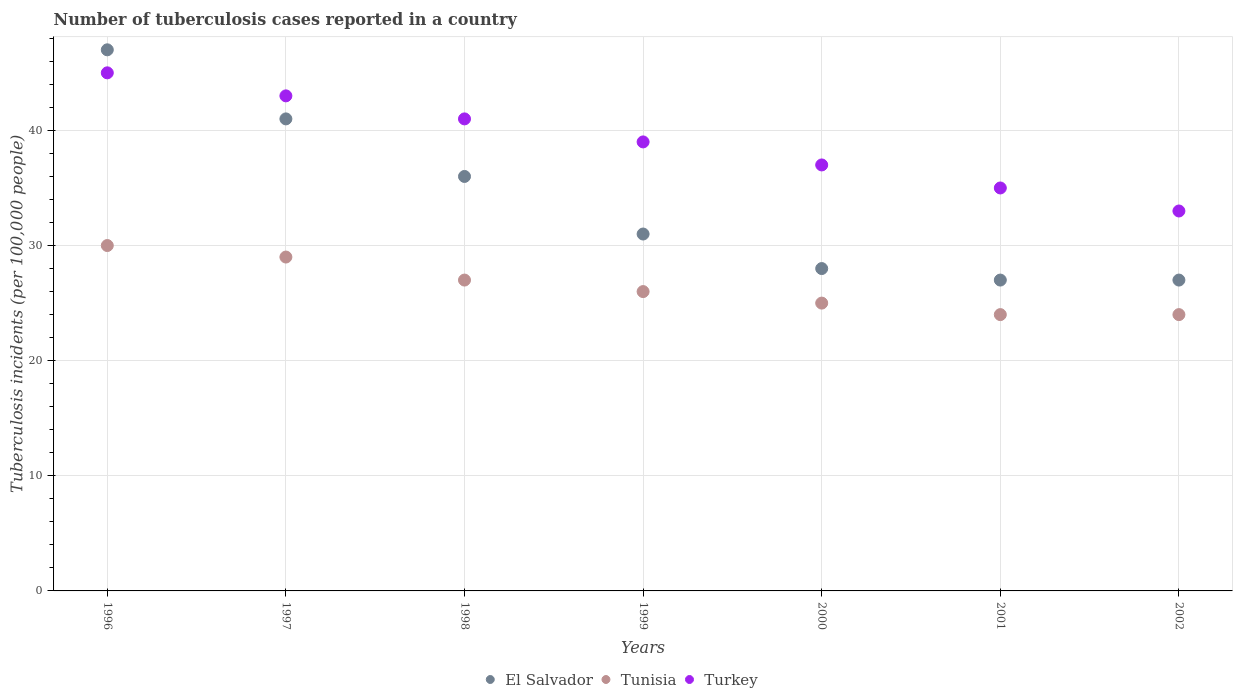What is the number of tuberculosis cases reported in in Turkey in 2000?
Make the answer very short. 37. Across all years, what is the maximum number of tuberculosis cases reported in in El Salvador?
Ensure brevity in your answer.  47. Across all years, what is the minimum number of tuberculosis cases reported in in El Salvador?
Provide a succinct answer. 27. In which year was the number of tuberculosis cases reported in in Turkey maximum?
Your response must be concise. 1996. In which year was the number of tuberculosis cases reported in in Tunisia minimum?
Your answer should be compact. 2001. What is the total number of tuberculosis cases reported in in Tunisia in the graph?
Give a very brief answer. 185. What is the difference between the number of tuberculosis cases reported in in Turkey in 2001 and the number of tuberculosis cases reported in in El Salvador in 2000?
Ensure brevity in your answer.  7. What is the average number of tuberculosis cases reported in in El Salvador per year?
Your answer should be very brief. 33.86. In the year 2001, what is the difference between the number of tuberculosis cases reported in in Tunisia and number of tuberculosis cases reported in in Turkey?
Your answer should be compact. -11. In how many years, is the number of tuberculosis cases reported in in Turkey greater than 32?
Your answer should be compact. 7. What is the ratio of the number of tuberculosis cases reported in in Turkey in 1997 to that in 1999?
Your answer should be compact. 1.1. Is the number of tuberculosis cases reported in in Turkey in 1998 less than that in 2001?
Ensure brevity in your answer.  No. What is the difference between the highest and the second highest number of tuberculosis cases reported in in El Salvador?
Provide a succinct answer. 6. What is the difference between the highest and the lowest number of tuberculosis cases reported in in Turkey?
Provide a short and direct response. 12. Is the sum of the number of tuberculosis cases reported in in Turkey in 1998 and 1999 greater than the maximum number of tuberculosis cases reported in in Tunisia across all years?
Provide a short and direct response. Yes. Is it the case that in every year, the sum of the number of tuberculosis cases reported in in Turkey and number of tuberculosis cases reported in in Tunisia  is greater than the number of tuberculosis cases reported in in El Salvador?
Your response must be concise. Yes. Is the number of tuberculosis cases reported in in Tunisia strictly greater than the number of tuberculosis cases reported in in El Salvador over the years?
Make the answer very short. No. Is the number of tuberculosis cases reported in in Turkey strictly less than the number of tuberculosis cases reported in in Tunisia over the years?
Your response must be concise. No. Does the graph contain any zero values?
Keep it short and to the point. No. How many legend labels are there?
Ensure brevity in your answer.  3. What is the title of the graph?
Offer a very short reply. Number of tuberculosis cases reported in a country. What is the label or title of the Y-axis?
Make the answer very short. Tuberculosis incidents (per 100,0 people). What is the Tuberculosis incidents (per 100,000 people) of Tunisia in 1996?
Your answer should be very brief. 30. What is the Tuberculosis incidents (per 100,000 people) in El Salvador in 1998?
Provide a short and direct response. 36. What is the Tuberculosis incidents (per 100,000 people) in Turkey in 1998?
Give a very brief answer. 41. What is the Tuberculosis incidents (per 100,000 people) in El Salvador in 1999?
Keep it short and to the point. 31. What is the Tuberculosis incidents (per 100,000 people) in El Salvador in 2000?
Your answer should be compact. 28. What is the Tuberculosis incidents (per 100,000 people) in Tunisia in 2000?
Keep it short and to the point. 25. What is the Tuberculosis incidents (per 100,000 people) in Turkey in 2000?
Make the answer very short. 37. What is the Tuberculosis incidents (per 100,000 people) in El Salvador in 2001?
Your response must be concise. 27. What is the Tuberculosis incidents (per 100,000 people) of Tunisia in 2001?
Ensure brevity in your answer.  24. What is the Tuberculosis incidents (per 100,000 people) in Turkey in 2001?
Provide a succinct answer. 35. Across all years, what is the maximum Tuberculosis incidents (per 100,000 people) of Tunisia?
Your answer should be compact. 30. Across all years, what is the maximum Tuberculosis incidents (per 100,000 people) of Turkey?
Make the answer very short. 45. Across all years, what is the minimum Tuberculosis incidents (per 100,000 people) of El Salvador?
Your response must be concise. 27. Across all years, what is the minimum Tuberculosis incidents (per 100,000 people) of Turkey?
Your response must be concise. 33. What is the total Tuberculosis incidents (per 100,000 people) of El Salvador in the graph?
Keep it short and to the point. 237. What is the total Tuberculosis incidents (per 100,000 people) in Tunisia in the graph?
Offer a very short reply. 185. What is the total Tuberculosis incidents (per 100,000 people) in Turkey in the graph?
Your answer should be compact. 273. What is the difference between the Tuberculosis incidents (per 100,000 people) in El Salvador in 1996 and that in 1997?
Keep it short and to the point. 6. What is the difference between the Tuberculosis incidents (per 100,000 people) of Turkey in 1996 and that in 1997?
Provide a short and direct response. 2. What is the difference between the Tuberculosis incidents (per 100,000 people) of Tunisia in 1996 and that in 1998?
Provide a succinct answer. 3. What is the difference between the Tuberculosis incidents (per 100,000 people) of Turkey in 1996 and that in 1998?
Ensure brevity in your answer.  4. What is the difference between the Tuberculosis incidents (per 100,000 people) of Turkey in 1996 and that in 2000?
Your answer should be very brief. 8. What is the difference between the Tuberculosis incidents (per 100,000 people) of Tunisia in 1996 and that in 2001?
Your answer should be very brief. 6. What is the difference between the Tuberculosis incidents (per 100,000 people) of El Salvador in 1996 and that in 2002?
Give a very brief answer. 20. What is the difference between the Tuberculosis incidents (per 100,000 people) in Tunisia in 1996 and that in 2002?
Your answer should be very brief. 6. What is the difference between the Tuberculosis incidents (per 100,000 people) in Turkey in 1996 and that in 2002?
Give a very brief answer. 12. What is the difference between the Tuberculosis incidents (per 100,000 people) in Turkey in 1997 and that in 1998?
Offer a very short reply. 2. What is the difference between the Tuberculosis incidents (per 100,000 people) of El Salvador in 1997 and that in 1999?
Your answer should be compact. 10. What is the difference between the Tuberculosis incidents (per 100,000 people) of Tunisia in 1997 and that in 1999?
Your answer should be very brief. 3. What is the difference between the Tuberculosis incidents (per 100,000 people) in El Salvador in 1997 and that in 2000?
Offer a very short reply. 13. What is the difference between the Tuberculosis incidents (per 100,000 people) of Tunisia in 1997 and that in 2000?
Offer a terse response. 4. What is the difference between the Tuberculosis incidents (per 100,000 people) of El Salvador in 1997 and that in 2001?
Keep it short and to the point. 14. What is the difference between the Tuberculosis incidents (per 100,000 people) in Tunisia in 1997 and that in 2001?
Make the answer very short. 5. What is the difference between the Tuberculosis incidents (per 100,000 people) in Turkey in 1997 and that in 2001?
Your answer should be very brief. 8. What is the difference between the Tuberculosis incidents (per 100,000 people) of Tunisia in 1997 and that in 2002?
Offer a terse response. 5. What is the difference between the Tuberculosis incidents (per 100,000 people) of Turkey in 1997 and that in 2002?
Offer a terse response. 10. What is the difference between the Tuberculosis incidents (per 100,000 people) of Tunisia in 1998 and that in 1999?
Ensure brevity in your answer.  1. What is the difference between the Tuberculosis incidents (per 100,000 people) of Tunisia in 1998 and that in 2000?
Make the answer very short. 2. What is the difference between the Tuberculosis incidents (per 100,000 people) of Turkey in 1998 and that in 2000?
Ensure brevity in your answer.  4. What is the difference between the Tuberculosis incidents (per 100,000 people) in Tunisia in 1998 and that in 2001?
Offer a very short reply. 3. What is the difference between the Tuberculosis incidents (per 100,000 people) of Turkey in 1998 and that in 2001?
Make the answer very short. 6. What is the difference between the Tuberculosis incidents (per 100,000 people) of El Salvador in 1998 and that in 2002?
Your answer should be very brief. 9. What is the difference between the Tuberculosis incidents (per 100,000 people) in Tunisia in 1998 and that in 2002?
Give a very brief answer. 3. What is the difference between the Tuberculosis incidents (per 100,000 people) in Turkey in 1998 and that in 2002?
Your answer should be compact. 8. What is the difference between the Tuberculosis incidents (per 100,000 people) of Turkey in 1999 and that in 2001?
Make the answer very short. 4. What is the difference between the Tuberculosis incidents (per 100,000 people) in Tunisia in 1999 and that in 2002?
Your response must be concise. 2. What is the difference between the Tuberculosis incidents (per 100,000 people) in Tunisia in 2000 and that in 2001?
Your answer should be very brief. 1. What is the difference between the Tuberculosis incidents (per 100,000 people) in Turkey in 2000 and that in 2002?
Your answer should be compact. 4. What is the difference between the Tuberculosis incidents (per 100,000 people) in Tunisia in 2001 and that in 2002?
Offer a terse response. 0. What is the difference between the Tuberculosis incidents (per 100,000 people) of Turkey in 2001 and that in 2002?
Keep it short and to the point. 2. What is the difference between the Tuberculosis incidents (per 100,000 people) of El Salvador in 1996 and the Tuberculosis incidents (per 100,000 people) of Tunisia in 1998?
Provide a short and direct response. 20. What is the difference between the Tuberculosis incidents (per 100,000 people) of El Salvador in 1996 and the Tuberculosis incidents (per 100,000 people) of Tunisia in 1999?
Offer a very short reply. 21. What is the difference between the Tuberculosis incidents (per 100,000 people) in El Salvador in 1996 and the Tuberculosis incidents (per 100,000 people) in Tunisia in 2001?
Provide a succinct answer. 23. What is the difference between the Tuberculosis incidents (per 100,000 people) in El Salvador in 1996 and the Tuberculosis incidents (per 100,000 people) in Turkey in 2001?
Your answer should be compact. 12. What is the difference between the Tuberculosis incidents (per 100,000 people) in Tunisia in 1996 and the Tuberculosis incidents (per 100,000 people) in Turkey in 2001?
Provide a short and direct response. -5. What is the difference between the Tuberculosis incidents (per 100,000 people) in El Salvador in 1996 and the Tuberculosis incidents (per 100,000 people) in Tunisia in 2002?
Make the answer very short. 23. What is the difference between the Tuberculosis incidents (per 100,000 people) in El Salvador in 1996 and the Tuberculosis incidents (per 100,000 people) in Turkey in 2002?
Keep it short and to the point. 14. What is the difference between the Tuberculosis incidents (per 100,000 people) of El Salvador in 1997 and the Tuberculosis incidents (per 100,000 people) of Turkey in 1998?
Your answer should be very brief. 0. What is the difference between the Tuberculosis incidents (per 100,000 people) of El Salvador in 1997 and the Tuberculosis incidents (per 100,000 people) of Turkey in 1999?
Offer a terse response. 2. What is the difference between the Tuberculosis incidents (per 100,000 people) of El Salvador in 1997 and the Tuberculosis incidents (per 100,000 people) of Turkey in 2000?
Ensure brevity in your answer.  4. What is the difference between the Tuberculosis incidents (per 100,000 people) of El Salvador in 1997 and the Tuberculosis incidents (per 100,000 people) of Tunisia in 2002?
Your answer should be compact. 17. What is the difference between the Tuberculosis incidents (per 100,000 people) of El Salvador in 1997 and the Tuberculosis incidents (per 100,000 people) of Turkey in 2002?
Keep it short and to the point. 8. What is the difference between the Tuberculosis incidents (per 100,000 people) in El Salvador in 1998 and the Tuberculosis incidents (per 100,000 people) in Tunisia in 1999?
Your answer should be compact. 10. What is the difference between the Tuberculosis incidents (per 100,000 people) of El Salvador in 1998 and the Tuberculosis incidents (per 100,000 people) of Turkey in 1999?
Provide a succinct answer. -3. What is the difference between the Tuberculosis incidents (per 100,000 people) in El Salvador in 1998 and the Tuberculosis incidents (per 100,000 people) in Turkey in 2000?
Keep it short and to the point. -1. What is the difference between the Tuberculosis incidents (per 100,000 people) of Tunisia in 1998 and the Tuberculosis incidents (per 100,000 people) of Turkey in 2000?
Your answer should be very brief. -10. What is the difference between the Tuberculosis incidents (per 100,000 people) in El Salvador in 1998 and the Tuberculosis incidents (per 100,000 people) in Turkey in 2001?
Make the answer very short. 1. What is the difference between the Tuberculosis incidents (per 100,000 people) of Tunisia in 1998 and the Tuberculosis incidents (per 100,000 people) of Turkey in 2001?
Ensure brevity in your answer.  -8. What is the difference between the Tuberculosis incidents (per 100,000 people) of El Salvador in 1998 and the Tuberculosis incidents (per 100,000 people) of Turkey in 2002?
Ensure brevity in your answer.  3. What is the difference between the Tuberculosis incidents (per 100,000 people) of El Salvador in 1999 and the Tuberculosis incidents (per 100,000 people) of Turkey in 2000?
Give a very brief answer. -6. What is the difference between the Tuberculosis incidents (per 100,000 people) in Tunisia in 1999 and the Tuberculosis incidents (per 100,000 people) in Turkey in 2000?
Make the answer very short. -11. What is the difference between the Tuberculosis incidents (per 100,000 people) in El Salvador in 1999 and the Tuberculosis incidents (per 100,000 people) in Turkey in 2001?
Provide a succinct answer. -4. What is the difference between the Tuberculosis incidents (per 100,000 people) of Tunisia in 1999 and the Tuberculosis incidents (per 100,000 people) of Turkey in 2001?
Offer a very short reply. -9. What is the difference between the Tuberculosis incidents (per 100,000 people) of El Salvador in 1999 and the Tuberculosis incidents (per 100,000 people) of Tunisia in 2002?
Give a very brief answer. 7. What is the difference between the Tuberculosis incidents (per 100,000 people) of Tunisia in 1999 and the Tuberculosis incidents (per 100,000 people) of Turkey in 2002?
Provide a short and direct response. -7. What is the difference between the Tuberculosis incidents (per 100,000 people) of El Salvador in 2000 and the Tuberculosis incidents (per 100,000 people) of Tunisia in 2001?
Make the answer very short. 4. What is the difference between the Tuberculosis incidents (per 100,000 people) of El Salvador in 2000 and the Tuberculosis incidents (per 100,000 people) of Turkey in 2001?
Offer a very short reply. -7. What is the difference between the Tuberculosis incidents (per 100,000 people) in El Salvador in 2000 and the Tuberculosis incidents (per 100,000 people) in Tunisia in 2002?
Provide a succinct answer. 4. What is the difference between the Tuberculosis incidents (per 100,000 people) of El Salvador in 2000 and the Tuberculosis incidents (per 100,000 people) of Turkey in 2002?
Your response must be concise. -5. What is the difference between the Tuberculosis incidents (per 100,000 people) of Tunisia in 2000 and the Tuberculosis incidents (per 100,000 people) of Turkey in 2002?
Provide a short and direct response. -8. What is the difference between the Tuberculosis incidents (per 100,000 people) in El Salvador in 2001 and the Tuberculosis incidents (per 100,000 people) in Tunisia in 2002?
Keep it short and to the point. 3. What is the difference between the Tuberculosis incidents (per 100,000 people) in El Salvador in 2001 and the Tuberculosis incidents (per 100,000 people) in Turkey in 2002?
Make the answer very short. -6. What is the average Tuberculosis incidents (per 100,000 people) in El Salvador per year?
Offer a terse response. 33.86. What is the average Tuberculosis incidents (per 100,000 people) of Tunisia per year?
Your response must be concise. 26.43. What is the average Tuberculosis incidents (per 100,000 people) in Turkey per year?
Offer a very short reply. 39. In the year 1996, what is the difference between the Tuberculosis incidents (per 100,000 people) of Tunisia and Tuberculosis incidents (per 100,000 people) of Turkey?
Provide a succinct answer. -15. In the year 1997, what is the difference between the Tuberculosis incidents (per 100,000 people) of Tunisia and Tuberculosis incidents (per 100,000 people) of Turkey?
Ensure brevity in your answer.  -14. In the year 1998, what is the difference between the Tuberculosis incidents (per 100,000 people) in El Salvador and Tuberculosis incidents (per 100,000 people) in Tunisia?
Give a very brief answer. 9. In the year 1999, what is the difference between the Tuberculosis incidents (per 100,000 people) of El Salvador and Tuberculosis incidents (per 100,000 people) of Tunisia?
Ensure brevity in your answer.  5. In the year 1999, what is the difference between the Tuberculosis incidents (per 100,000 people) of El Salvador and Tuberculosis incidents (per 100,000 people) of Turkey?
Your answer should be compact. -8. In the year 2000, what is the difference between the Tuberculosis incidents (per 100,000 people) in El Salvador and Tuberculosis incidents (per 100,000 people) in Turkey?
Offer a terse response. -9. In the year 2001, what is the difference between the Tuberculosis incidents (per 100,000 people) in El Salvador and Tuberculosis incidents (per 100,000 people) in Tunisia?
Your answer should be very brief. 3. In the year 2001, what is the difference between the Tuberculosis incidents (per 100,000 people) in Tunisia and Tuberculosis incidents (per 100,000 people) in Turkey?
Your answer should be very brief. -11. In the year 2002, what is the difference between the Tuberculosis incidents (per 100,000 people) in El Salvador and Tuberculosis incidents (per 100,000 people) in Tunisia?
Your answer should be very brief. 3. In the year 2002, what is the difference between the Tuberculosis incidents (per 100,000 people) in Tunisia and Tuberculosis incidents (per 100,000 people) in Turkey?
Give a very brief answer. -9. What is the ratio of the Tuberculosis incidents (per 100,000 people) of El Salvador in 1996 to that in 1997?
Ensure brevity in your answer.  1.15. What is the ratio of the Tuberculosis incidents (per 100,000 people) in Tunisia in 1996 to that in 1997?
Make the answer very short. 1.03. What is the ratio of the Tuberculosis incidents (per 100,000 people) of Turkey in 1996 to that in 1997?
Provide a succinct answer. 1.05. What is the ratio of the Tuberculosis incidents (per 100,000 people) in El Salvador in 1996 to that in 1998?
Offer a terse response. 1.31. What is the ratio of the Tuberculosis incidents (per 100,000 people) of Tunisia in 1996 to that in 1998?
Your response must be concise. 1.11. What is the ratio of the Tuberculosis incidents (per 100,000 people) of Turkey in 1996 to that in 1998?
Your answer should be compact. 1.1. What is the ratio of the Tuberculosis incidents (per 100,000 people) of El Salvador in 1996 to that in 1999?
Offer a terse response. 1.52. What is the ratio of the Tuberculosis incidents (per 100,000 people) of Tunisia in 1996 to that in 1999?
Offer a very short reply. 1.15. What is the ratio of the Tuberculosis incidents (per 100,000 people) in Turkey in 1996 to that in 1999?
Your answer should be compact. 1.15. What is the ratio of the Tuberculosis incidents (per 100,000 people) in El Salvador in 1996 to that in 2000?
Offer a terse response. 1.68. What is the ratio of the Tuberculosis incidents (per 100,000 people) of Tunisia in 1996 to that in 2000?
Provide a succinct answer. 1.2. What is the ratio of the Tuberculosis incidents (per 100,000 people) of Turkey in 1996 to that in 2000?
Provide a short and direct response. 1.22. What is the ratio of the Tuberculosis incidents (per 100,000 people) in El Salvador in 1996 to that in 2001?
Keep it short and to the point. 1.74. What is the ratio of the Tuberculosis incidents (per 100,000 people) in Turkey in 1996 to that in 2001?
Provide a short and direct response. 1.29. What is the ratio of the Tuberculosis incidents (per 100,000 people) in El Salvador in 1996 to that in 2002?
Keep it short and to the point. 1.74. What is the ratio of the Tuberculosis incidents (per 100,000 people) in Turkey in 1996 to that in 2002?
Provide a succinct answer. 1.36. What is the ratio of the Tuberculosis incidents (per 100,000 people) of El Salvador in 1997 to that in 1998?
Your response must be concise. 1.14. What is the ratio of the Tuberculosis incidents (per 100,000 people) in Tunisia in 1997 to that in 1998?
Your response must be concise. 1.07. What is the ratio of the Tuberculosis incidents (per 100,000 people) in Turkey in 1997 to that in 1998?
Your response must be concise. 1.05. What is the ratio of the Tuberculosis incidents (per 100,000 people) of El Salvador in 1997 to that in 1999?
Give a very brief answer. 1.32. What is the ratio of the Tuberculosis incidents (per 100,000 people) of Tunisia in 1997 to that in 1999?
Provide a short and direct response. 1.12. What is the ratio of the Tuberculosis incidents (per 100,000 people) of Turkey in 1997 to that in 1999?
Keep it short and to the point. 1.1. What is the ratio of the Tuberculosis incidents (per 100,000 people) in El Salvador in 1997 to that in 2000?
Provide a short and direct response. 1.46. What is the ratio of the Tuberculosis incidents (per 100,000 people) of Tunisia in 1997 to that in 2000?
Give a very brief answer. 1.16. What is the ratio of the Tuberculosis incidents (per 100,000 people) in Turkey in 1997 to that in 2000?
Your answer should be very brief. 1.16. What is the ratio of the Tuberculosis incidents (per 100,000 people) of El Salvador in 1997 to that in 2001?
Keep it short and to the point. 1.52. What is the ratio of the Tuberculosis incidents (per 100,000 people) of Tunisia in 1997 to that in 2001?
Make the answer very short. 1.21. What is the ratio of the Tuberculosis incidents (per 100,000 people) of Turkey in 1997 to that in 2001?
Provide a short and direct response. 1.23. What is the ratio of the Tuberculosis incidents (per 100,000 people) of El Salvador in 1997 to that in 2002?
Offer a terse response. 1.52. What is the ratio of the Tuberculosis incidents (per 100,000 people) of Tunisia in 1997 to that in 2002?
Provide a succinct answer. 1.21. What is the ratio of the Tuberculosis incidents (per 100,000 people) in Turkey in 1997 to that in 2002?
Your answer should be very brief. 1.3. What is the ratio of the Tuberculosis incidents (per 100,000 people) in El Salvador in 1998 to that in 1999?
Give a very brief answer. 1.16. What is the ratio of the Tuberculosis incidents (per 100,000 people) of Tunisia in 1998 to that in 1999?
Provide a short and direct response. 1.04. What is the ratio of the Tuberculosis incidents (per 100,000 people) of Turkey in 1998 to that in 1999?
Offer a very short reply. 1.05. What is the ratio of the Tuberculosis incidents (per 100,000 people) in Turkey in 1998 to that in 2000?
Offer a very short reply. 1.11. What is the ratio of the Tuberculosis incidents (per 100,000 people) of El Salvador in 1998 to that in 2001?
Make the answer very short. 1.33. What is the ratio of the Tuberculosis incidents (per 100,000 people) in Turkey in 1998 to that in 2001?
Your answer should be very brief. 1.17. What is the ratio of the Tuberculosis incidents (per 100,000 people) in Tunisia in 1998 to that in 2002?
Provide a succinct answer. 1.12. What is the ratio of the Tuberculosis incidents (per 100,000 people) in Turkey in 1998 to that in 2002?
Give a very brief answer. 1.24. What is the ratio of the Tuberculosis incidents (per 100,000 people) of El Salvador in 1999 to that in 2000?
Your answer should be compact. 1.11. What is the ratio of the Tuberculosis incidents (per 100,000 people) of Turkey in 1999 to that in 2000?
Your answer should be very brief. 1.05. What is the ratio of the Tuberculosis incidents (per 100,000 people) of El Salvador in 1999 to that in 2001?
Your response must be concise. 1.15. What is the ratio of the Tuberculosis incidents (per 100,000 people) of Tunisia in 1999 to that in 2001?
Offer a terse response. 1.08. What is the ratio of the Tuberculosis incidents (per 100,000 people) of Turkey in 1999 to that in 2001?
Offer a terse response. 1.11. What is the ratio of the Tuberculosis incidents (per 100,000 people) of El Salvador in 1999 to that in 2002?
Offer a very short reply. 1.15. What is the ratio of the Tuberculosis incidents (per 100,000 people) of Tunisia in 1999 to that in 2002?
Your response must be concise. 1.08. What is the ratio of the Tuberculosis incidents (per 100,000 people) in Turkey in 1999 to that in 2002?
Your answer should be compact. 1.18. What is the ratio of the Tuberculosis incidents (per 100,000 people) in Tunisia in 2000 to that in 2001?
Your answer should be compact. 1.04. What is the ratio of the Tuberculosis incidents (per 100,000 people) of Turkey in 2000 to that in 2001?
Provide a short and direct response. 1.06. What is the ratio of the Tuberculosis incidents (per 100,000 people) in El Salvador in 2000 to that in 2002?
Keep it short and to the point. 1.04. What is the ratio of the Tuberculosis incidents (per 100,000 people) in Tunisia in 2000 to that in 2002?
Ensure brevity in your answer.  1.04. What is the ratio of the Tuberculosis incidents (per 100,000 people) of Turkey in 2000 to that in 2002?
Give a very brief answer. 1.12. What is the ratio of the Tuberculosis incidents (per 100,000 people) of Tunisia in 2001 to that in 2002?
Make the answer very short. 1. What is the ratio of the Tuberculosis incidents (per 100,000 people) in Turkey in 2001 to that in 2002?
Keep it short and to the point. 1.06. What is the difference between the highest and the lowest Tuberculosis incidents (per 100,000 people) of Tunisia?
Ensure brevity in your answer.  6. What is the difference between the highest and the lowest Tuberculosis incidents (per 100,000 people) in Turkey?
Keep it short and to the point. 12. 